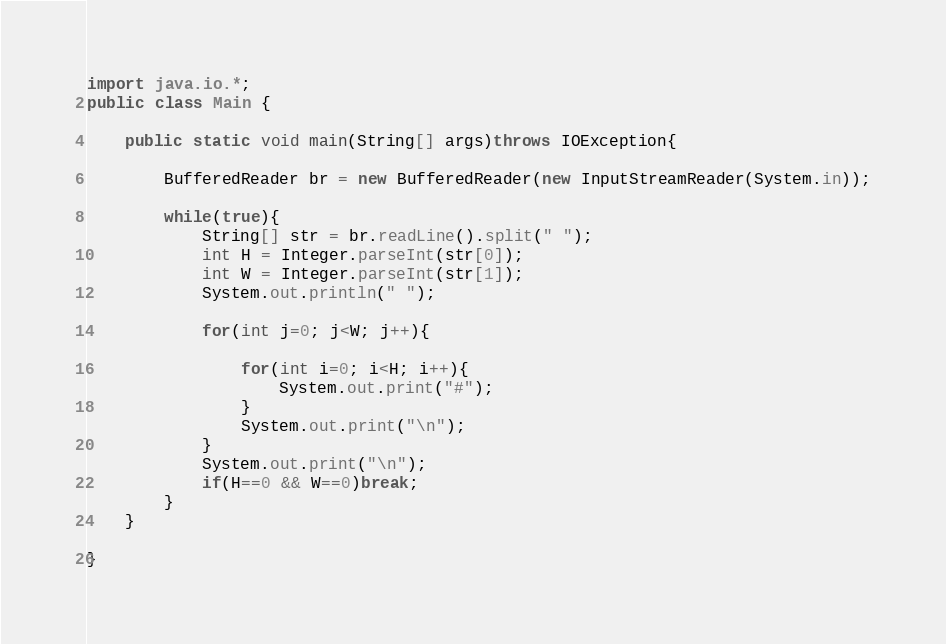Convert code to text. <code><loc_0><loc_0><loc_500><loc_500><_Java_>import java.io.*;
public class Main {
	
	public static void main(String[] args)throws IOException{
		
		BufferedReader br = new BufferedReader(new InputStreamReader(System.in));
		
		while(true){
			String[] str = br.readLine().split(" ");
			int H = Integer.parseInt(str[0]);
			int W = Integer.parseInt(str[1]);
			System.out.println(" ");
			
			for(int j=0; j<W; j++){
			
				for(int i=0; i<H; i++){
					System.out.print("#");
				}
				System.out.print("\n");
			}
			System.out.print("\n");
			if(H==0 && W==0)break;
		}
	}

}</code> 